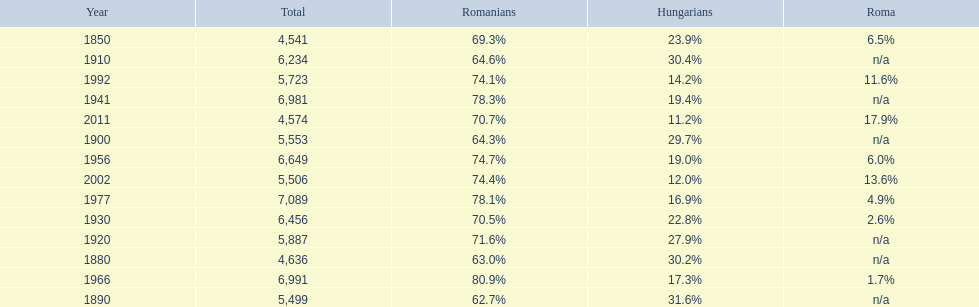Which year had the top percentage in romanian population? 1966. 